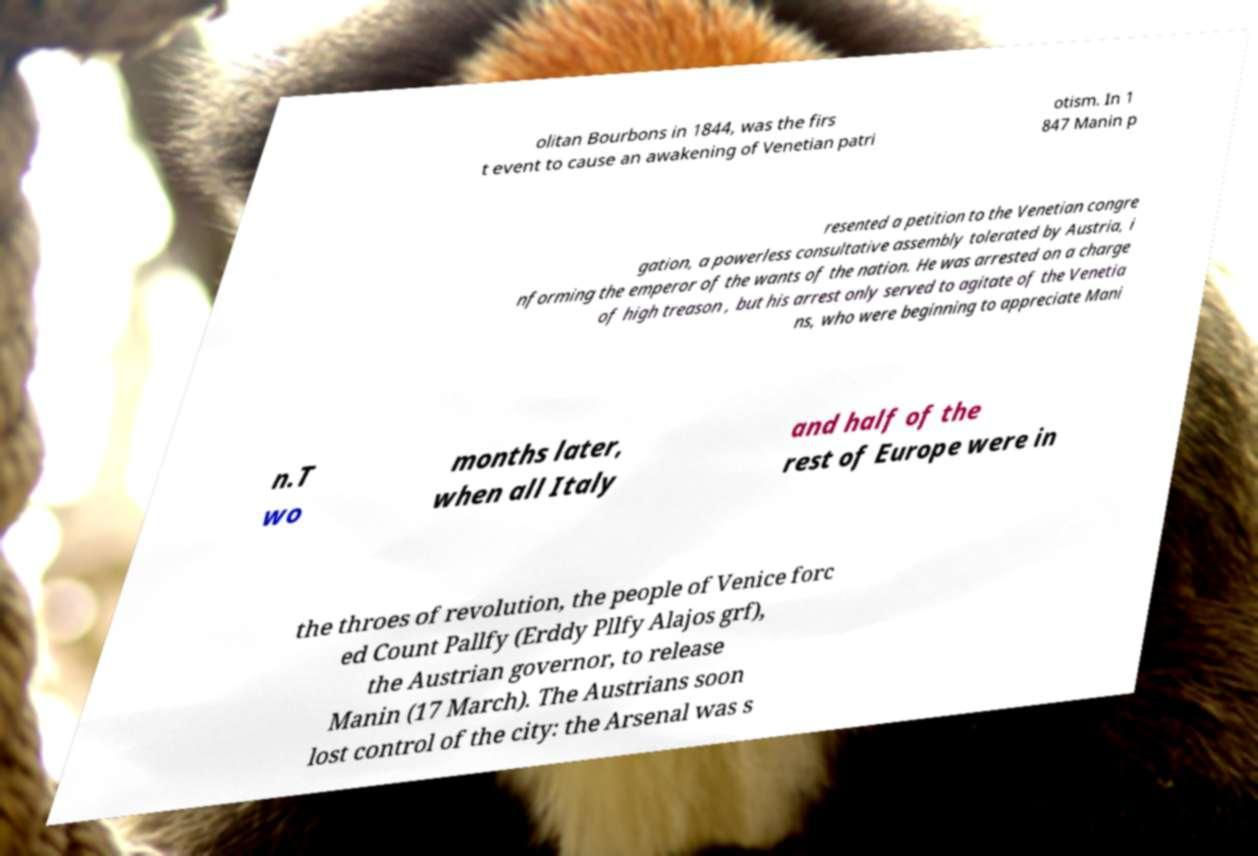Could you assist in decoding the text presented in this image and type it out clearly? olitan Bourbons in 1844, was the firs t event to cause an awakening of Venetian patri otism. In 1 847 Manin p resented a petition to the Venetian congre gation, a powerless consultative assembly tolerated by Austria, i nforming the emperor of the wants of the nation. He was arrested on a charge of high treason , but his arrest only served to agitate of the Venetia ns, who were beginning to appreciate Mani n.T wo months later, when all Italy and half of the rest of Europe were in the throes of revolution, the people of Venice forc ed Count Pallfy (Erddy Pllfy Alajos grf), the Austrian governor, to release Manin (17 March). The Austrians soon lost control of the city: the Arsenal was s 